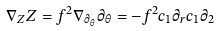Convert formula to latex. <formula><loc_0><loc_0><loc_500><loc_500>\nabla _ { Z } Z = f ^ { 2 } \nabla _ { \partial _ { \theta } } \partial _ { \theta } = - f ^ { 2 } c _ { 1 } \partial _ { r } c _ { 1 } \partial _ { 2 }</formula> 